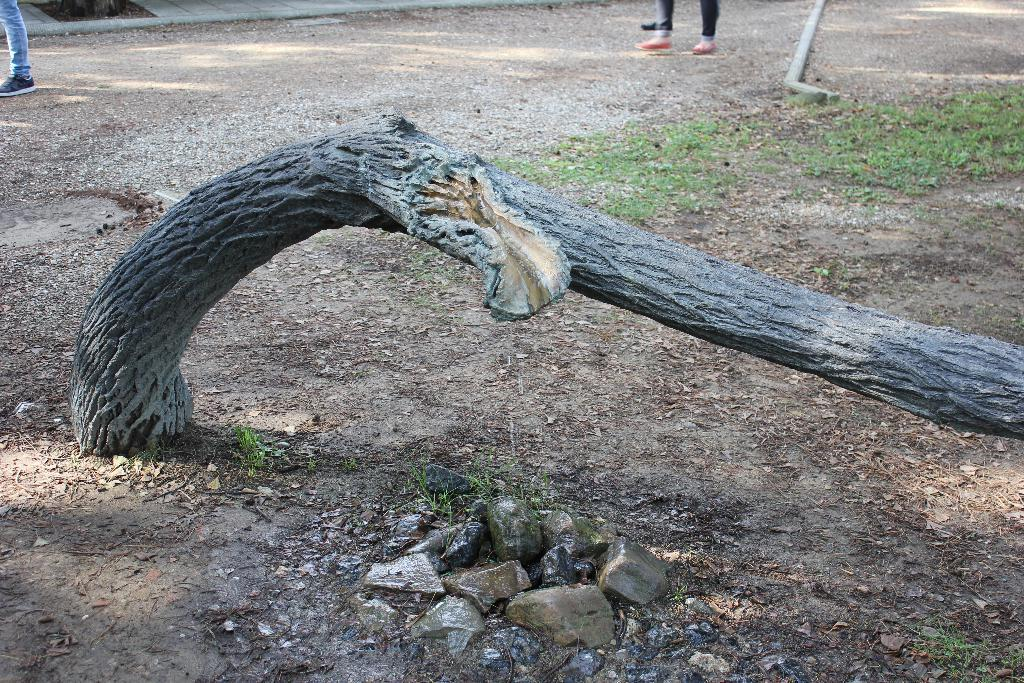What object is the main focus of the image? There is a trunk in the image. What can be seen in the background of the image? There are people standing in the background of the image. What type of vegetation is visible in the image? There is green-colored grass visible in the image. What type of produce is being sold at the hospital in the image? There is no produce or hospital present in the image; it features a trunk and people in the background. 